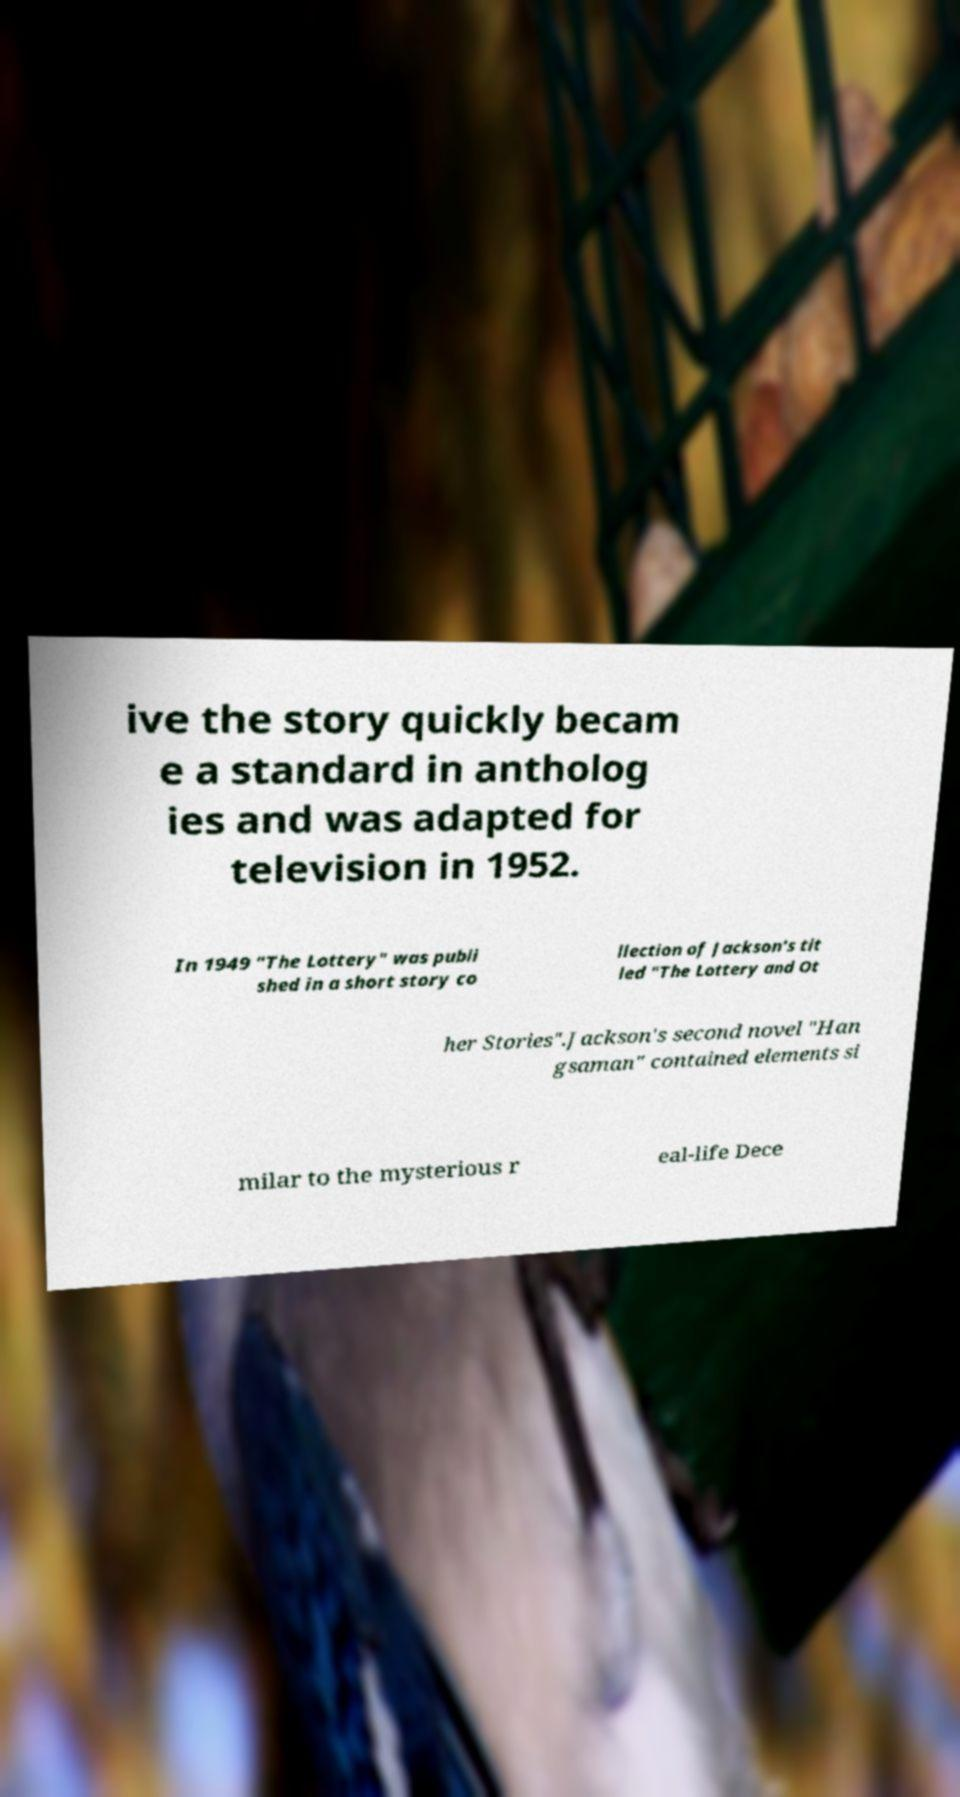For documentation purposes, I need the text within this image transcribed. Could you provide that? ive the story quickly becam e a standard in antholog ies and was adapted for television in 1952. In 1949 "The Lottery" was publi shed in a short story co llection of Jackson's tit led "The Lottery and Ot her Stories".Jackson's second novel "Han gsaman" contained elements si milar to the mysterious r eal-life Dece 